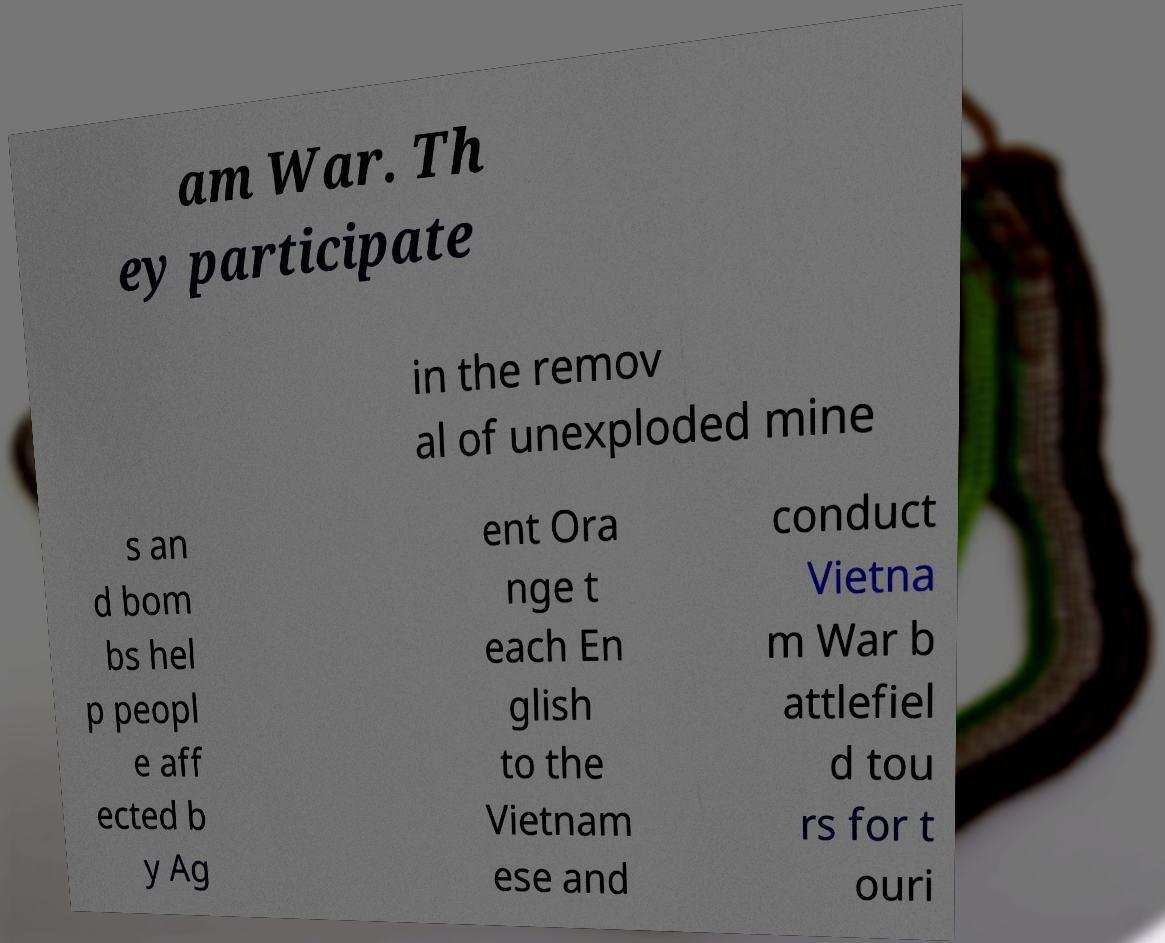Could you assist in decoding the text presented in this image and type it out clearly? am War. Th ey participate in the remov al of unexploded mine s an d bom bs hel p peopl e aff ected b y Ag ent Ora nge t each En glish to the Vietnam ese and conduct Vietna m War b attlefiel d tou rs for t ouri 